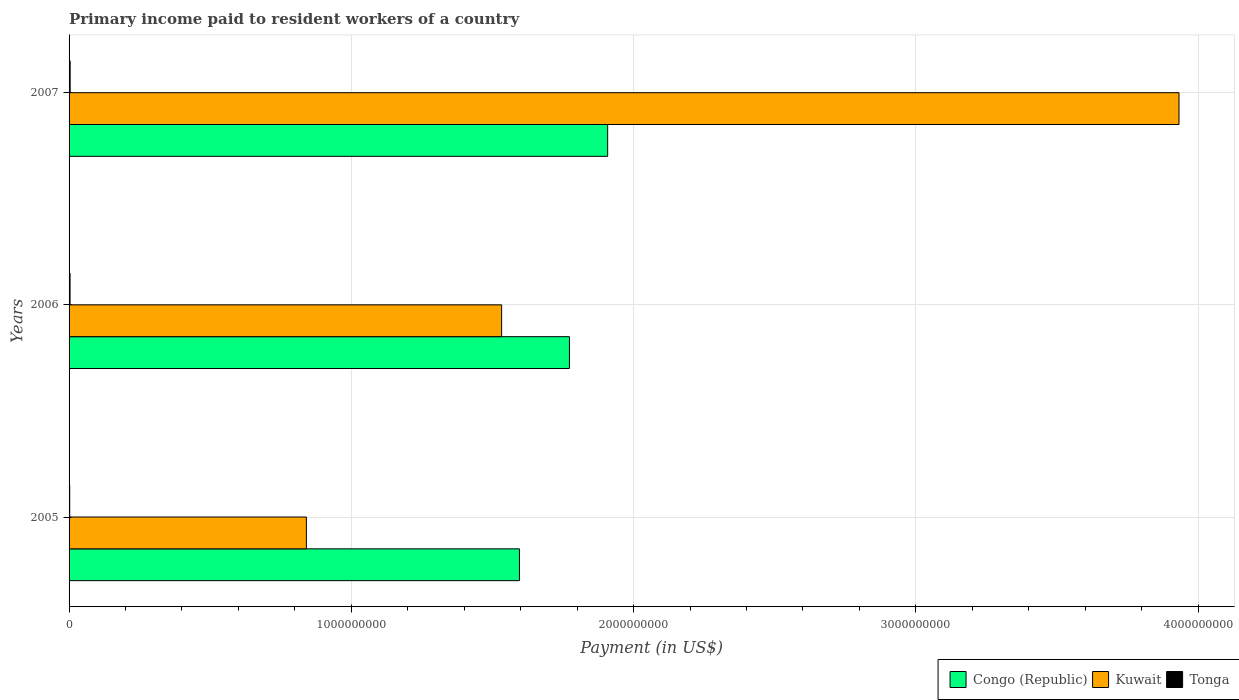How many different coloured bars are there?
Provide a succinct answer. 3. Are the number of bars per tick equal to the number of legend labels?
Your response must be concise. Yes. How many bars are there on the 3rd tick from the top?
Your answer should be very brief. 3. How many bars are there on the 3rd tick from the bottom?
Offer a very short reply. 3. In how many cases, is the number of bars for a given year not equal to the number of legend labels?
Keep it short and to the point. 0. What is the amount paid to workers in Kuwait in 2006?
Give a very brief answer. 1.53e+09. Across all years, what is the maximum amount paid to workers in Kuwait?
Your answer should be very brief. 3.93e+09. Across all years, what is the minimum amount paid to workers in Kuwait?
Your answer should be very brief. 8.41e+08. What is the total amount paid to workers in Tonga in the graph?
Your response must be concise. 9.52e+06. What is the difference between the amount paid to workers in Tonga in 2005 and that in 2006?
Make the answer very short. -1.18e+06. What is the difference between the amount paid to workers in Congo (Republic) in 2006 and the amount paid to workers in Kuwait in 2007?
Ensure brevity in your answer.  -2.16e+09. What is the average amount paid to workers in Congo (Republic) per year?
Provide a short and direct response. 1.76e+09. In the year 2005, what is the difference between the amount paid to workers in Kuwait and amount paid to workers in Congo (Republic)?
Give a very brief answer. -7.55e+08. What is the ratio of the amount paid to workers in Tonga in 2006 to that in 2007?
Provide a short and direct response. 0.91. Is the amount paid to workers in Kuwait in 2005 less than that in 2007?
Provide a succinct answer. Yes. What is the difference between the highest and the second highest amount paid to workers in Tonga?
Give a very brief answer. 3.58e+05. What is the difference between the highest and the lowest amount paid to workers in Tonga?
Offer a very short reply. 1.54e+06. In how many years, is the amount paid to workers in Kuwait greater than the average amount paid to workers in Kuwait taken over all years?
Offer a very short reply. 1. What does the 2nd bar from the top in 2005 represents?
Ensure brevity in your answer.  Kuwait. What does the 2nd bar from the bottom in 2006 represents?
Provide a succinct answer. Kuwait. Is it the case that in every year, the sum of the amount paid to workers in Tonga and amount paid to workers in Kuwait is greater than the amount paid to workers in Congo (Republic)?
Give a very brief answer. No. How many bars are there?
Make the answer very short. 9. Are all the bars in the graph horizontal?
Give a very brief answer. Yes. What is the difference between two consecutive major ticks on the X-axis?
Your response must be concise. 1.00e+09. Does the graph contain any zero values?
Your response must be concise. No. Does the graph contain grids?
Offer a terse response. Yes. Where does the legend appear in the graph?
Keep it short and to the point. Bottom right. What is the title of the graph?
Provide a succinct answer. Primary income paid to resident workers of a country. Does "Lower middle income" appear as one of the legend labels in the graph?
Your answer should be compact. No. What is the label or title of the X-axis?
Provide a succinct answer. Payment (in US$). What is the Payment (in US$) in Congo (Republic) in 2005?
Give a very brief answer. 1.60e+09. What is the Payment (in US$) of Kuwait in 2005?
Provide a short and direct response. 8.41e+08. What is the Payment (in US$) in Tonga in 2005?
Make the answer very short. 2.27e+06. What is the Payment (in US$) in Congo (Republic) in 2006?
Offer a terse response. 1.77e+09. What is the Payment (in US$) of Kuwait in 2006?
Your answer should be very brief. 1.53e+09. What is the Payment (in US$) of Tonga in 2006?
Your answer should be compact. 3.45e+06. What is the Payment (in US$) in Congo (Republic) in 2007?
Make the answer very short. 1.91e+09. What is the Payment (in US$) of Kuwait in 2007?
Give a very brief answer. 3.93e+09. What is the Payment (in US$) of Tonga in 2007?
Provide a short and direct response. 3.81e+06. Across all years, what is the maximum Payment (in US$) in Congo (Republic)?
Your answer should be compact. 1.91e+09. Across all years, what is the maximum Payment (in US$) of Kuwait?
Give a very brief answer. 3.93e+09. Across all years, what is the maximum Payment (in US$) of Tonga?
Your answer should be very brief. 3.81e+06. Across all years, what is the minimum Payment (in US$) of Congo (Republic)?
Offer a very short reply. 1.60e+09. Across all years, what is the minimum Payment (in US$) in Kuwait?
Make the answer very short. 8.41e+08. Across all years, what is the minimum Payment (in US$) of Tonga?
Provide a succinct answer. 2.27e+06. What is the total Payment (in US$) in Congo (Republic) in the graph?
Ensure brevity in your answer.  5.28e+09. What is the total Payment (in US$) in Kuwait in the graph?
Your response must be concise. 6.31e+09. What is the total Payment (in US$) of Tonga in the graph?
Your answer should be compact. 9.52e+06. What is the difference between the Payment (in US$) of Congo (Republic) in 2005 and that in 2006?
Ensure brevity in your answer.  -1.77e+08. What is the difference between the Payment (in US$) of Kuwait in 2005 and that in 2006?
Your answer should be very brief. -6.92e+08. What is the difference between the Payment (in US$) of Tonga in 2005 and that in 2006?
Your answer should be very brief. -1.18e+06. What is the difference between the Payment (in US$) in Congo (Republic) in 2005 and that in 2007?
Provide a short and direct response. -3.13e+08. What is the difference between the Payment (in US$) of Kuwait in 2005 and that in 2007?
Keep it short and to the point. -3.09e+09. What is the difference between the Payment (in US$) of Tonga in 2005 and that in 2007?
Make the answer very short. -1.54e+06. What is the difference between the Payment (in US$) in Congo (Republic) in 2006 and that in 2007?
Give a very brief answer. -1.35e+08. What is the difference between the Payment (in US$) in Kuwait in 2006 and that in 2007?
Give a very brief answer. -2.40e+09. What is the difference between the Payment (in US$) in Tonga in 2006 and that in 2007?
Ensure brevity in your answer.  -3.58e+05. What is the difference between the Payment (in US$) in Congo (Republic) in 2005 and the Payment (in US$) in Kuwait in 2006?
Your answer should be very brief. 6.30e+07. What is the difference between the Payment (in US$) in Congo (Republic) in 2005 and the Payment (in US$) in Tonga in 2006?
Your response must be concise. 1.59e+09. What is the difference between the Payment (in US$) of Kuwait in 2005 and the Payment (in US$) of Tonga in 2006?
Offer a terse response. 8.37e+08. What is the difference between the Payment (in US$) in Congo (Republic) in 2005 and the Payment (in US$) in Kuwait in 2007?
Keep it short and to the point. -2.34e+09. What is the difference between the Payment (in US$) in Congo (Republic) in 2005 and the Payment (in US$) in Tonga in 2007?
Your answer should be very brief. 1.59e+09. What is the difference between the Payment (in US$) in Kuwait in 2005 and the Payment (in US$) in Tonga in 2007?
Your response must be concise. 8.37e+08. What is the difference between the Payment (in US$) of Congo (Republic) in 2006 and the Payment (in US$) of Kuwait in 2007?
Keep it short and to the point. -2.16e+09. What is the difference between the Payment (in US$) in Congo (Republic) in 2006 and the Payment (in US$) in Tonga in 2007?
Your response must be concise. 1.77e+09. What is the difference between the Payment (in US$) of Kuwait in 2006 and the Payment (in US$) of Tonga in 2007?
Keep it short and to the point. 1.53e+09. What is the average Payment (in US$) of Congo (Republic) per year?
Your answer should be very brief. 1.76e+09. What is the average Payment (in US$) in Kuwait per year?
Provide a short and direct response. 2.10e+09. What is the average Payment (in US$) of Tonga per year?
Provide a succinct answer. 3.17e+06. In the year 2005, what is the difference between the Payment (in US$) in Congo (Republic) and Payment (in US$) in Kuwait?
Keep it short and to the point. 7.55e+08. In the year 2005, what is the difference between the Payment (in US$) in Congo (Republic) and Payment (in US$) in Tonga?
Provide a succinct answer. 1.59e+09. In the year 2005, what is the difference between the Payment (in US$) in Kuwait and Payment (in US$) in Tonga?
Ensure brevity in your answer.  8.38e+08. In the year 2006, what is the difference between the Payment (in US$) in Congo (Republic) and Payment (in US$) in Kuwait?
Your response must be concise. 2.40e+08. In the year 2006, what is the difference between the Payment (in US$) in Congo (Republic) and Payment (in US$) in Tonga?
Your answer should be very brief. 1.77e+09. In the year 2006, what is the difference between the Payment (in US$) of Kuwait and Payment (in US$) of Tonga?
Make the answer very short. 1.53e+09. In the year 2007, what is the difference between the Payment (in US$) in Congo (Republic) and Payment (in US$) in Kuwait?
Your answer should be very brief. -2.02e+09. In the year 2007, what is the difference between the Payment (in US$) in Congo (Republic) and Payment (in US$) in Tonga?
Make the answer very short. 1.90e+09. In the year 2007, what is the difference between the Payment (in US$) in Kuwait and Payment (in US$) in Tonga?
Provide a succinct answer. 3.93e+09. What is the ratio of the Payment (in US$) of Congo (Republic) in 2005 to that in 2006?
Your response must be concise. 0.9. What is the ratio of the Payment (in US$) in Kuwait in 2005 to that in 2006?
Provide a succinct answer. 0.55. What is the ratio of the Payment (in US$) in Tonga in 2005 to that in 2006?
Offer a very short reply. 0.66. What is the ratio of the Payment (in US$) of Congo (Republic) in 2005 to that in 2007?
Provide a succinct answer. 0.84. What is the ratio of the Payment (in US$) in Kuwait in 2005 to that in 2007?
Your answer should be very brief. 0.21. What is the ratio of the Payment (in US$) in Tonga in 2005 to that in 2007?
Provide a succinct answer. 0.6. What is the ratio of the Payment (in US$) of Congo (Republic) in 2006 to that in 2007?
Provide a short and direct response. 0.93. What is the ratio of the Payment (in US$) in Kuwait in 2006 to that in 2007?
Your answer should be compact. 0.39. What is the ratio of the Payment (in US$) in Tonga in 2006 to that in 2007?
Your answer should be compact. 0.91. What is the difference between the highest and the second highest Payment (in US$) in Congo (Republic)?
Keep it short and to the point. 1.35e+08. What is the difference between the highest and the second highest Payment (in US$) in Kuwait?
Your answer should be compact. 2.40e+09. What is the difference between the highest and the second highest Payment (in US$) of Tonga?
Offer a very short reply. 3.58e+05. What is the difference between the highest and the lowest Payment (in US$) of Congo (Republic)?
Make the answer very short. 3.13e+08. What is the difference between the highest and the lowest Payment (in US$) in Kuwait?
Provide a succinct answer. 3.09e+09. What is the difference between the highest and the lowest Payment (in US$) in Tonga?
Your answer should be compact. 1.54e+06. 